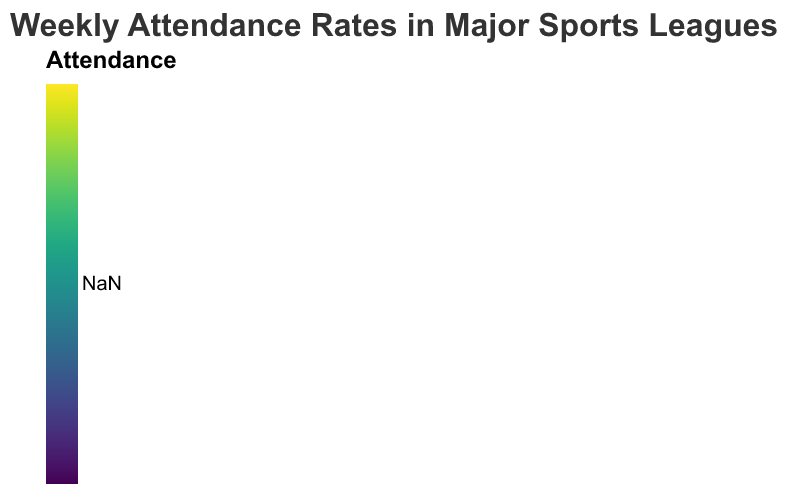Which week had the highest NFL attendance in the East region? Look at the East region rows and compare the NFL attendance values for each week. The week with the highest value is the answer.
Answer: 2023-10-02 Which region had the lowest NHL attendance on 2023-09-25? Check the NHL attendance values for each region on 2023-09-25. Identify the region with the smallest value.
Answer: Midwest What is the total attendance for NBA in the South region across all weeks? Sum the NBA attendance values for the South region for each week. The values are 155000, 150000, and 153000. The total is 155000 + 150000 + 153000.
Answer: 458000 Which sport had the highest average weekly attendance in the Midwest region? Calculate the average weekly attendance for each sport in the Midwest region by summing the attendance values for each sport and dividing by the number of weeks (3). Then, compare the averages.
Answer: NBA What is the difference in NFL attendance between the highest week in the West region and the lowest week in the West region? Identify the highest (240000 on 2023-09-25) and the lowest (230000 on 2023-10-09) NFL attendance values in the West region. Subtract the lowest value from the highest value. 240000 - 230000.
Answer: 10000 Which region had a consistent NHL attendance of 82000 across multiple weeks? Check the NHL attendance values for each region and identify if any region has entries with 82000 in multiple weeks. The South region has 82000 on both 2023-09-25 and 2023-10-09.
Answer: South What is the combined total attendance for MLB and NHL in the East region for the week of 2023-10-02? Add the MLB and NHL attendance values for the East region on 2023-10-02. MLB is 125000 and NHL is 87000. The combined total is 125000 + 87000.
Answer: 212000 How did NBA attendance in the West region change from 2023-09-25 to 2023-10-09? Compare the NBA attendance values for the West region on 2023-09-25 (140000) and 2023-10-09 (142000). The difference is 142000 - 140000.
Answer: Increased by 2000 Which week had the highest overall sports attendance in the South region? Sum attendance across all sports for each week in the South region and compare. The highest total is for 2023-10-02 with (250000 + 150000 + 120000 + 84000).
Answer: 2023-10-02 